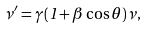Convert formula to latex. <formula><loc_0><loc_0><loc_500><loc_500>\nu ^ { \prime } = \gamma ( 1 + \beta \cos \theta ) \nu ,</formula> 